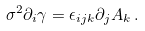Convert formula to latex. <formula><loc_0><loc_0><loc_500><loc_500>\sigma ^ { 2 } \partial _ { i } \gamma = \epsilon _ { i j k } \partial _ { j } A _ { k } \, .</formula> 